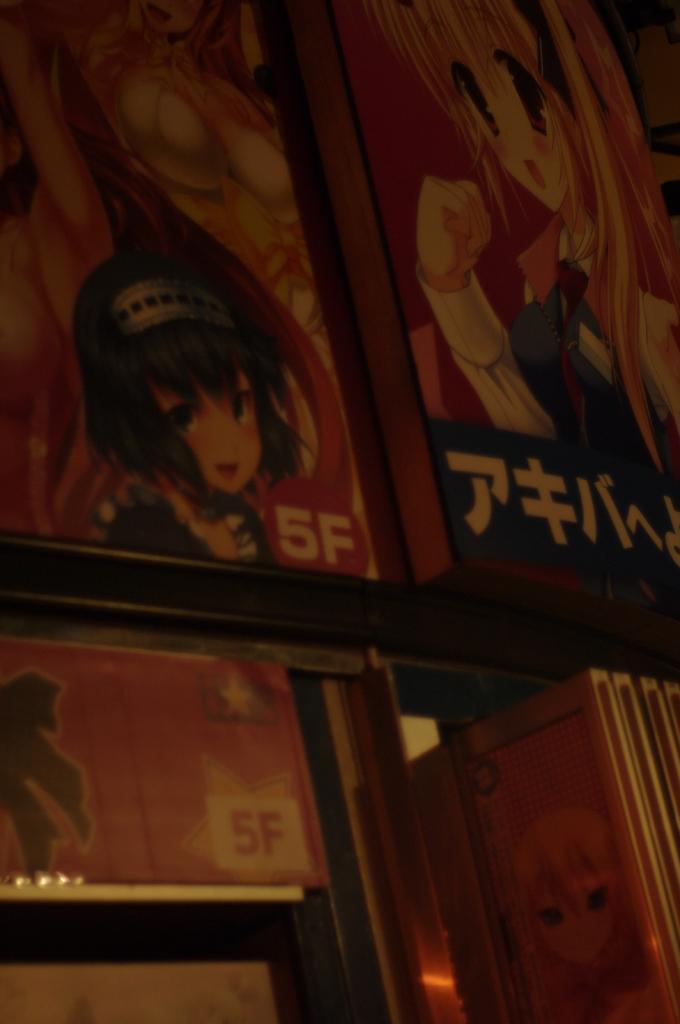Could you give a brief overview of what you see in this image? In this image I can see few wooden boards. On these I can see some text and few cartoon images. 